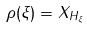<formula> <loc_0><loc_0><loc_500><loc_500>\rho ( \xi ) = X _ { H _ { \xi } }</formula> 